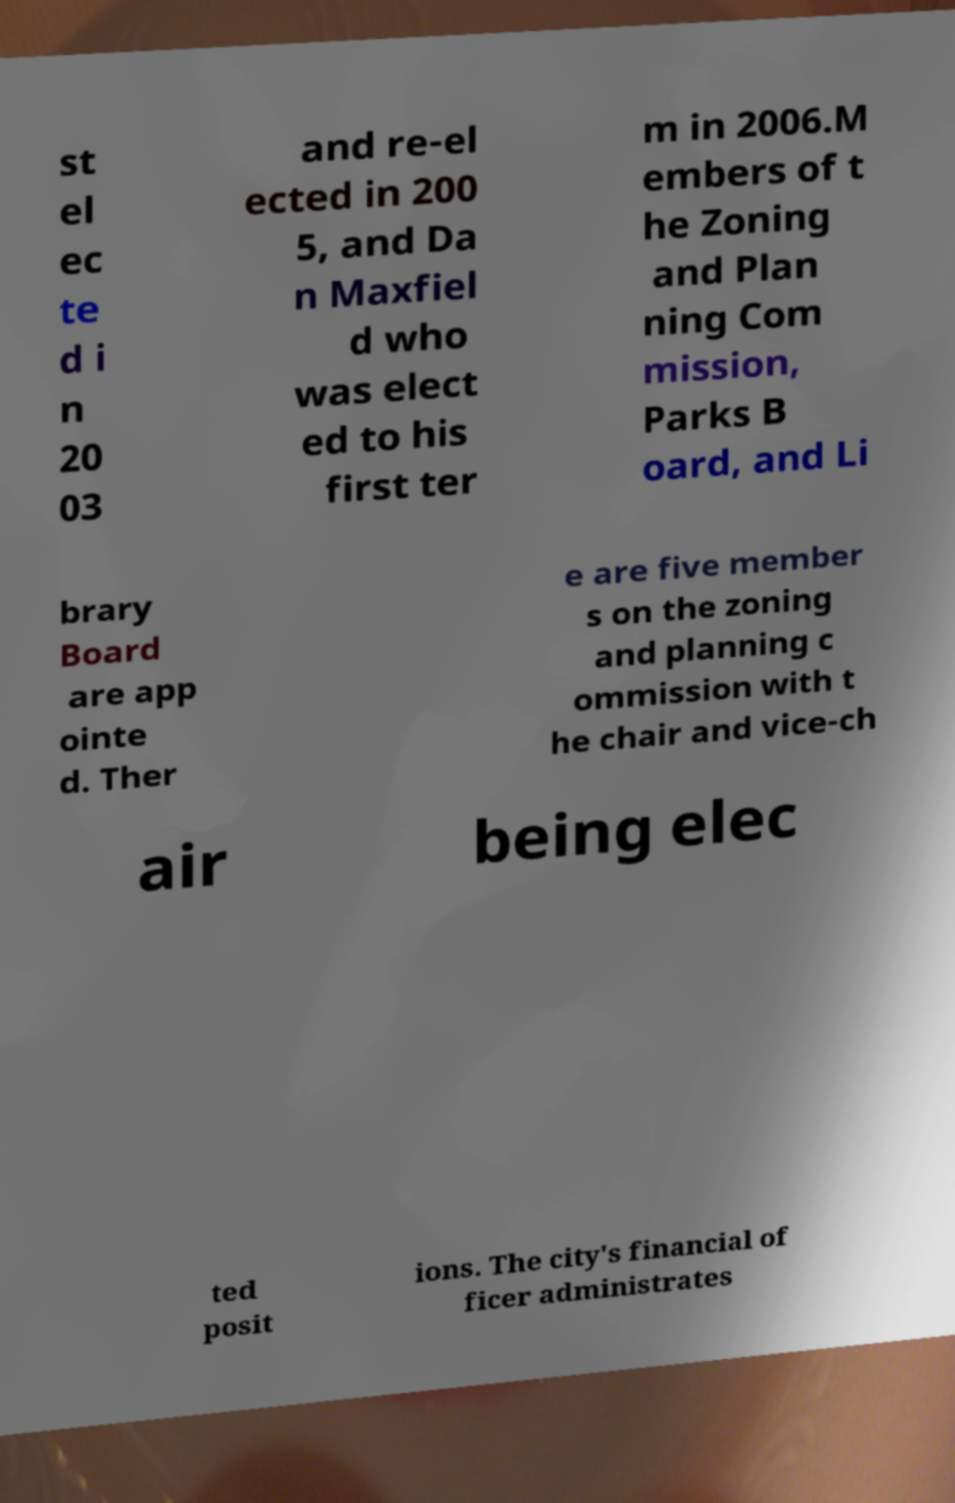There's text embedded in this image that I need extracted. Can you transcribe it verbatim? st el ec te d i n 20 03 and re-el ected in 200 5, and Da n Maxfiel d who was elect ed to his first ter m in 2006.M embers of t he Zoning and Plan ning Com mission, Parks B oard, and Li brary Board are app ointe d. Ther e are five member s on the zoning and planning c ommission with t he chair and vice-ch air being elec ted posit ions. The city's financial of ficer administrates 